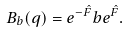Convert formula to latex. <formula><loc_0><loc_0><loc_500><loc_500>B _ { b } ( q ) = e ^ { - \hat { F } } b e ^ { \hat { F } } .</formula> 